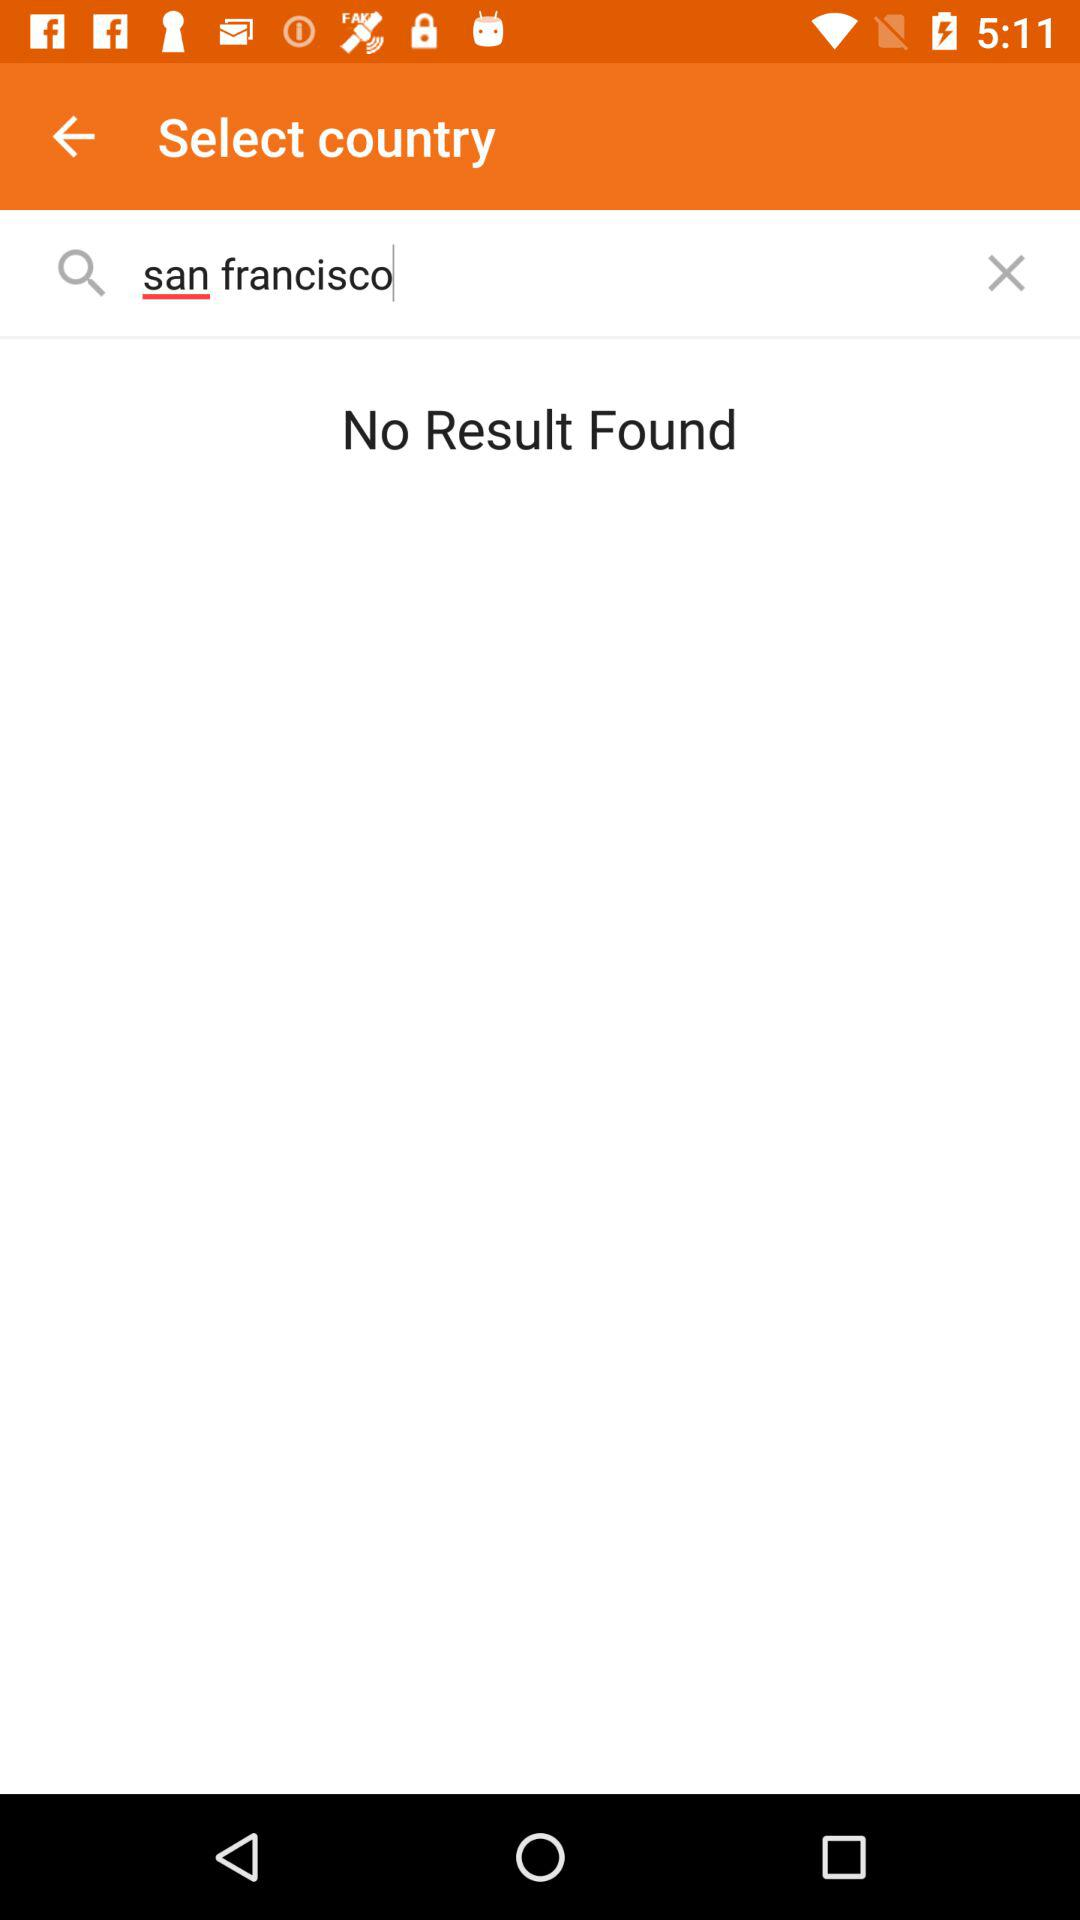What is the selected country?
When the provided information is insufficient, respond with <no answer>. <no answer> 